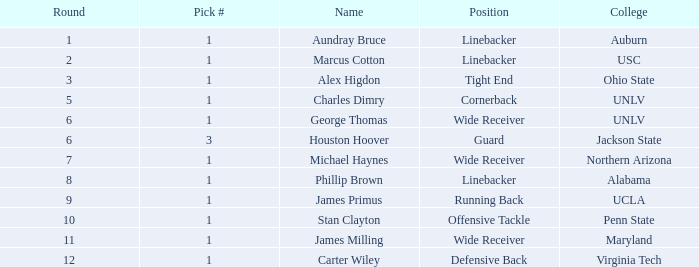In which round with a total exceeding 306 was the selection from virginia tech college? 0.0. 